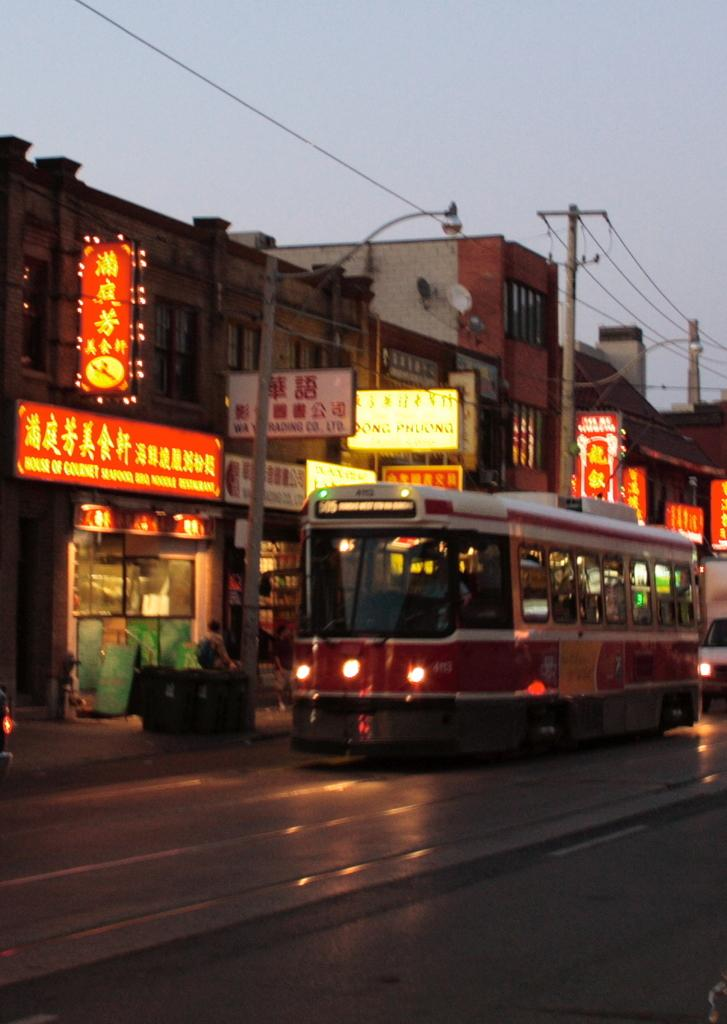What can be seen on the road in the image? There are vehicles on the road in the image. What structures are present in the image? There are buildings in the image. What are the poles used for in the image? The poles are likely used for supporting wires or lights in the image. What are the boards used for in the image? The boards might be used for signage or advertisements in the image. What are the wires used for in the image? The wires are likely used for transmitting electricity or communication signals in the image. What are the lights used for in the image? The lights might be used for illumination or signaling in the image. What objects can be seen in the image? There are various objects present in the image, including vehicles, buildings, poles, boards, wires, and lights. Who or what is present in the image? There is a person in the image. What can be seen in the background of the image? The sky is visible in the background of the image. What type of suit is the person wearing in the image? There is no information about the person's clothing in the image, so we cannot determine if they are wearing a suit or not. How much debt does the person in the image owe? There is no information about the person's financial situation in the image, so we cannot determine if they have any debt or not. 